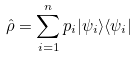Convert formula to latex. <formula><loc_0><loc_0><loc_500><loc_500>\hat { \rho } = \sum _ { i = 1 } ^ { n } p _ { i } | \psi _ { i } \rangle \langle \psi _ { i } |</formula> 